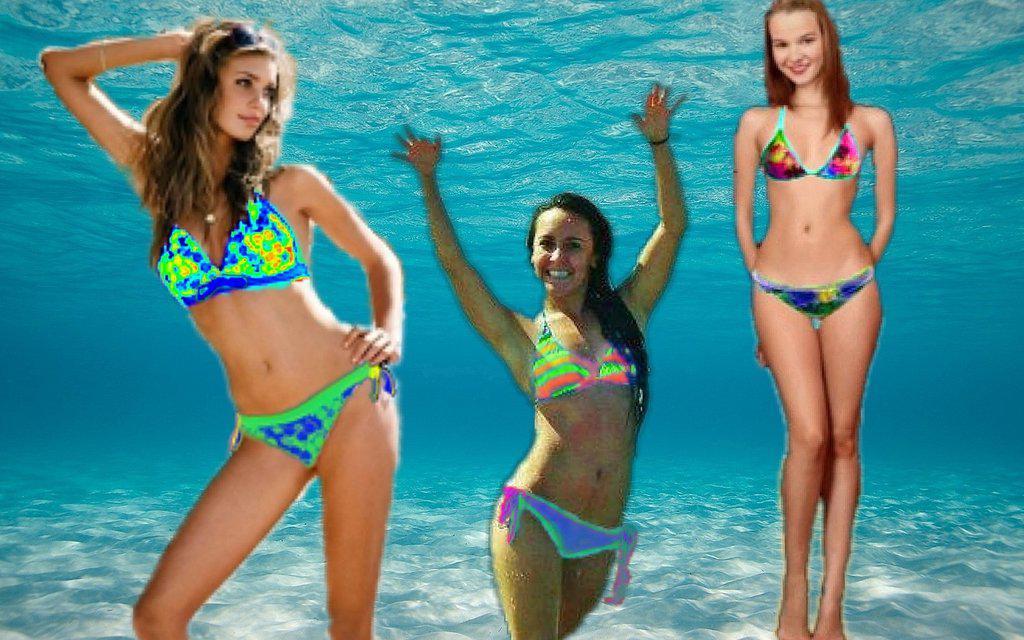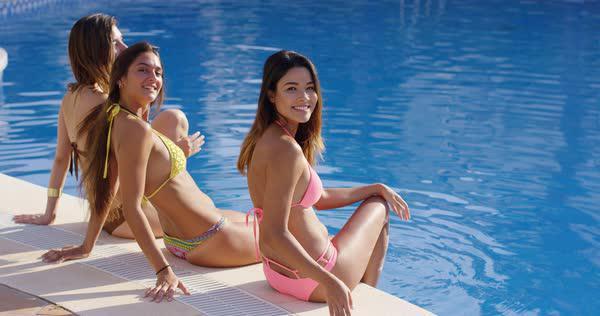The first image is the image on the left, the second image is the image on the right. Considering the images on both sides, is "One of the images shows exactly one woman sitting at the beach wearing a bikini." valid? Answer yes or no. No. The first image is the image on the left, the second image is the image on the right. For the images shown, is this caption "There is a female wearing a pink bikini in the right image." true? Answer yes or no. Yes. 